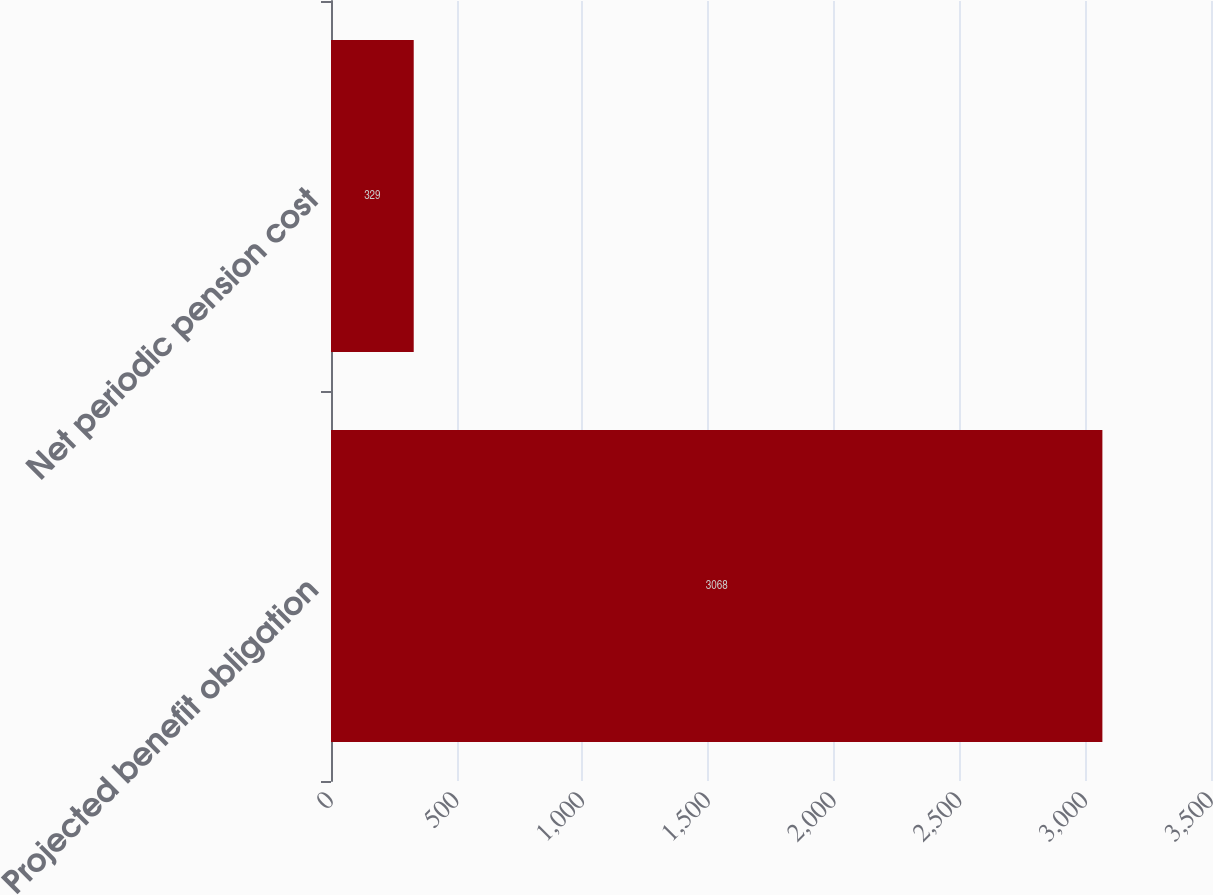Convert chart to OTSL. <chart><loc_0><loc_0><loc_500><loc_500><bar_chart><fcel>Projected benefit obligation<fcel>Net periodic pension cost<nl><fcel>3068<fcel>329<nl></chart> 